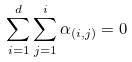<formula> <loc_0><loc_0><loc_500><loc_500>\sum _ { i = 1 } ^ { d } \sum _ { j = 1 } ^ { i } \alpha _ { ( i , j ) } = 0</formula> 